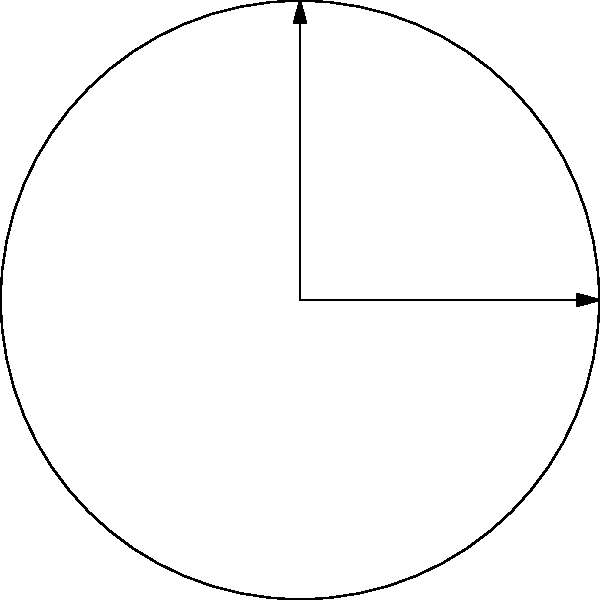In designing a circular memorial garden for LGBTQ activists, you want to create three flower beds in specific locations. The garden has a radius of 10 meters. The first bed, dedicated to Elaine Romagnoli, is plotted from $0°$ to $60°$ with a radius of 5 meters. The second bed, honoring Marsha P. Johnson, is from $120°$ to $180°$ with a radius of 7.5 meters. The third bed, commemorating Harvey Milk, is from $240°$ to $300°$ with a radius of 6 meters. What is the total area of all three flower beds in square meters? (Use $\pi \approx 3.14$) To find the total area, we need to calculate the area of each sector and sum them up:

1. For Elaine Romagnoli's bed:
   Angle: $60° = \frac{\pi}{3}$ radians
   Radius: 5 meters
   Area = $\frac{1}{2} r^2 \theta = \frac{1}{2} (5^2) (\frac{\pi}{3}) = \frac{25\pi}{6} \approx 13.08$ m²

2. For Marsha P. Johnson's bed:
   Angle: $60° = \frac{\pi}{3}$ radians
   Radius: 7.5 meters
   Area = $\frac{1}{2} r^2 \theta = \frac{1}{2} (7.5^2) (\frac{\pi}{3}) = \frac{75\pi}{8} \approx 29.44$ m²

3. For Harvey Milk's bed:
   Angle: $60° = \frac{\pi}{3}$ radians
   Radius: 6 meters
   Area = $\frac{1}{2} r^2 \theta = \frac{1}{2} (6^2) (\frac{\pi}{3}) = 6\pi \approx 18.84$ m²

Total area = $\frac{25\pi}{6} + \frac{75\pi}{8} + 6\pi \approx 13.08 + 29.44 + 18.84 = 61.36$ m²
Answer: 61.36 m² 